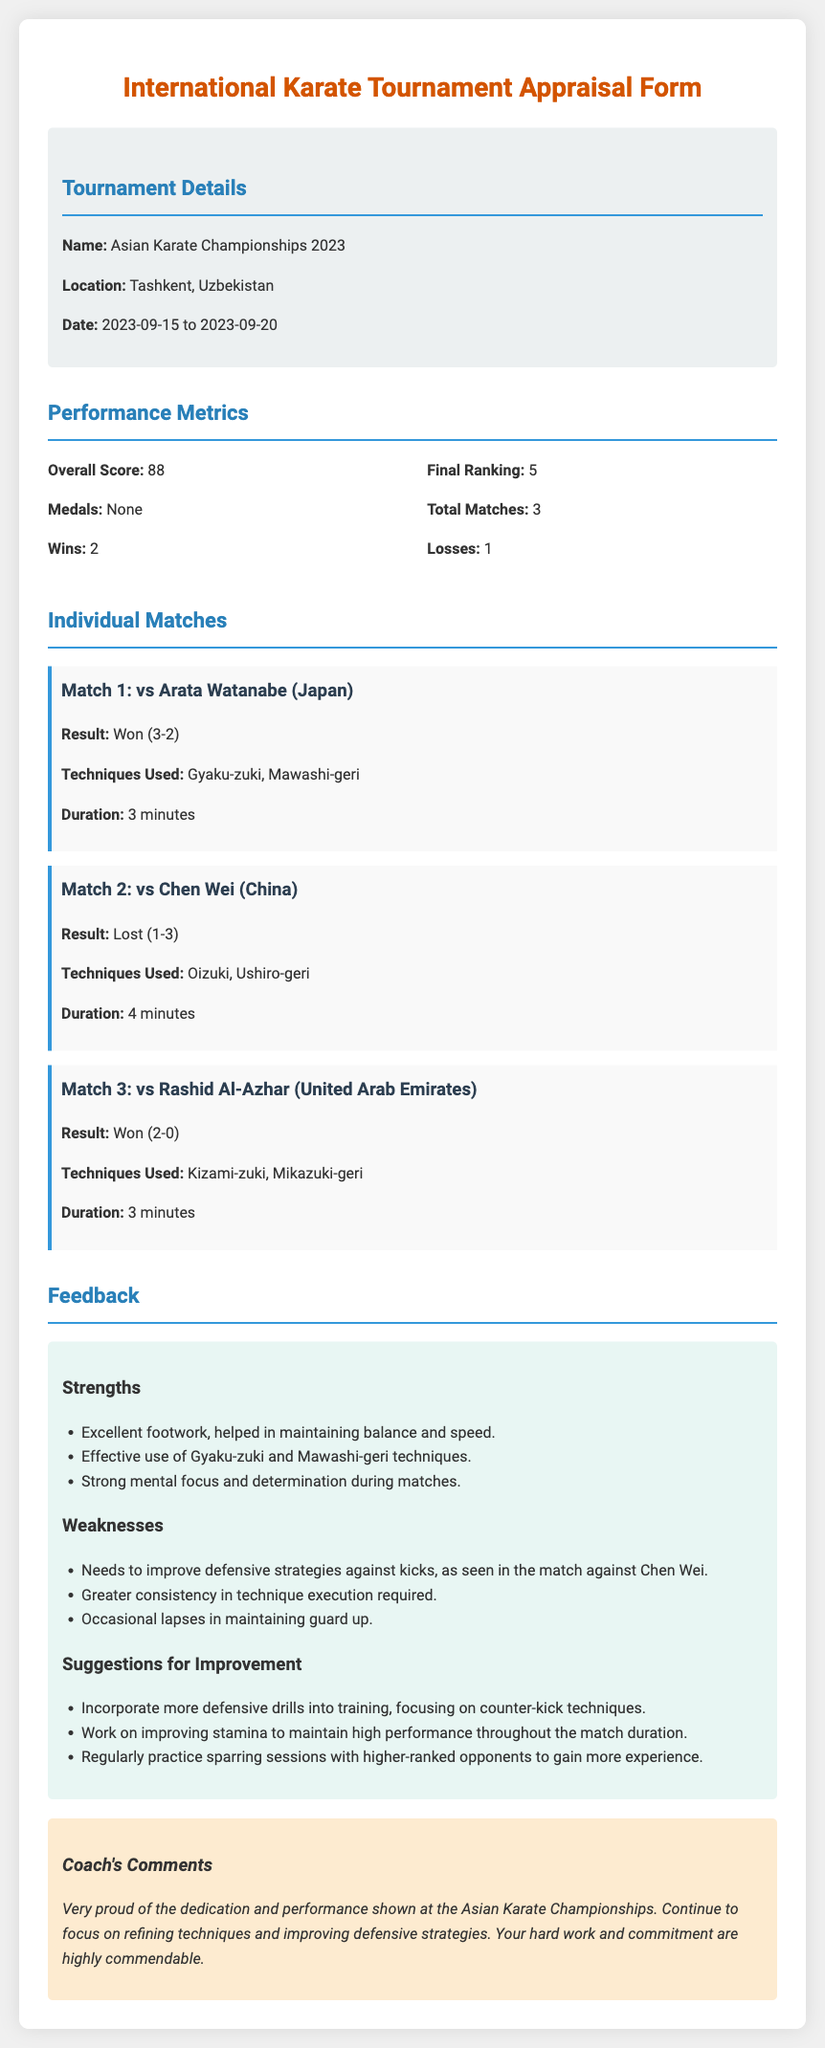What is the name of the tournament? The name of the tournament is stated in the document under Tournament Details.
Answer: Asian Karate Championships 2023 What was your final ranking? The final ranking is provided in the Performance Metrics section of the document.
Answer: 5 How many total matches were played? The total matches are listed in the Performance Metrics section.
Answer: 3 What was the result of the match against Arata Watanabe? The result of the match is detailed in the Individual Matches section.
Answer: Won (3-2) What weakness is highlighted regarding defensive strategies? A specific weakness regarding defensive strategies is mentioned in the Weaknesses section.
Answer: Needs to improve defensive strategies against kicks Based on the feedback, what should you incorporate into your training? Suggestions for improvement are provided in the Feedback section.
Answer: Defensive drills What is your overall score? The overall score is mentioned in the Performance Metrics section.
Answer: 88 How many wins were recorded during the tournament? The number of wins is shown in the Performance Metrics section.
Answer: 2 What is the coach's overall comment on your performance? The coach's comments can be found towards the end of the document.
Answer: Very proud of the dedication and performance shown 